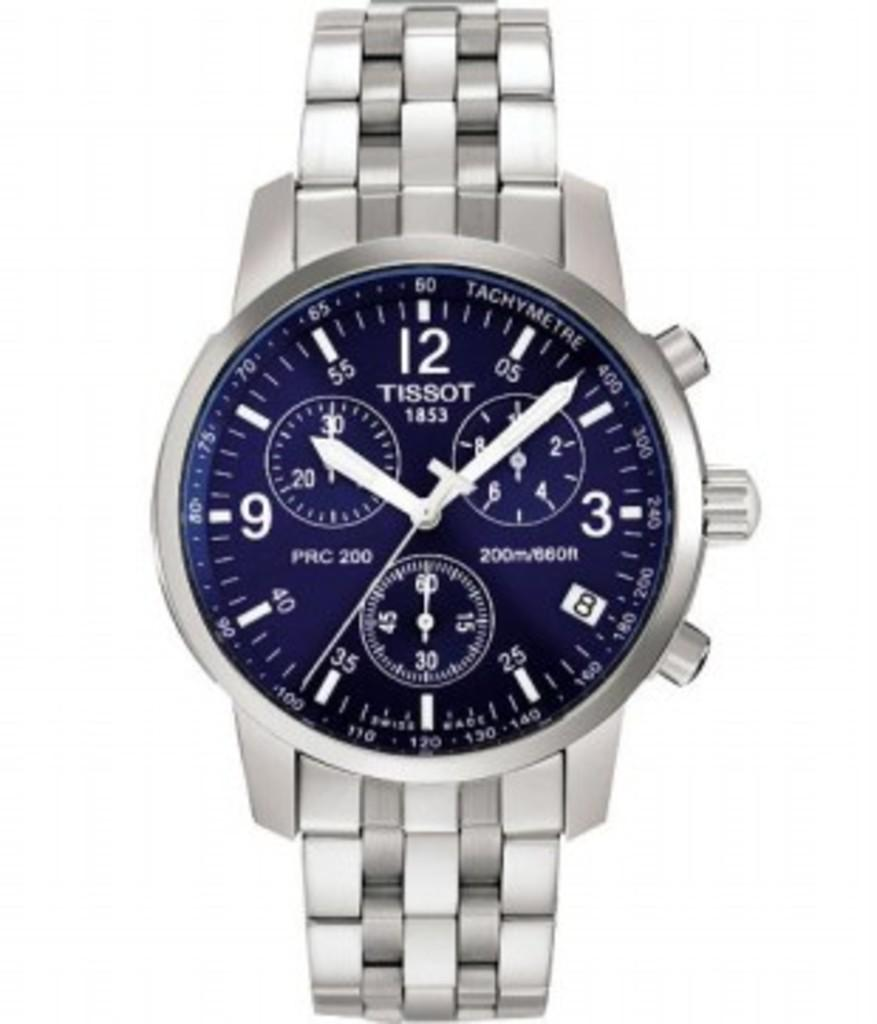<image>
Write a terse but informative summary of the picture. silver Tissot 1853 watch that has 3 smaller gauges on it also 